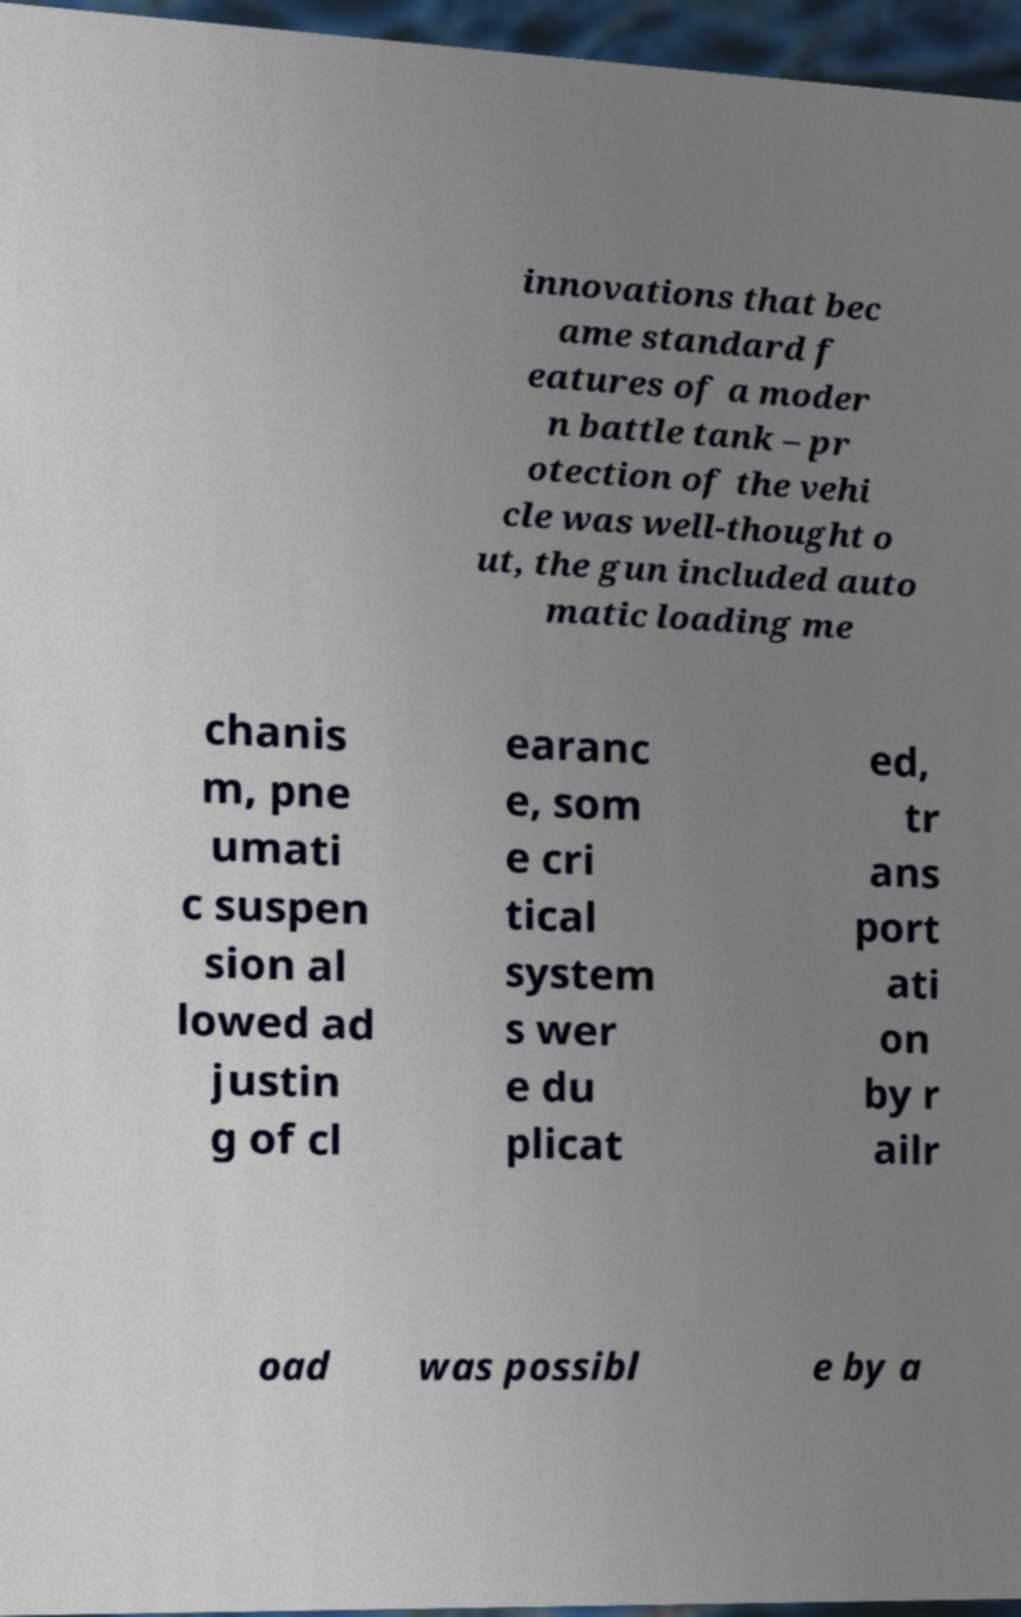Could you assist in decoding the text presented in this image and type it out clearly? innovations that bec ame standard f eatures of a moder n battle tank – pr otection of the vehi cle was well-thought o ut, the gun included auto matic loading me chanis m, pne umati c suspen sion al lowed ad justin g of cl earanc e, som e cri tical system s wer e du plicat ed, tr ans port ati on by r ailr oad was possibl e by a 